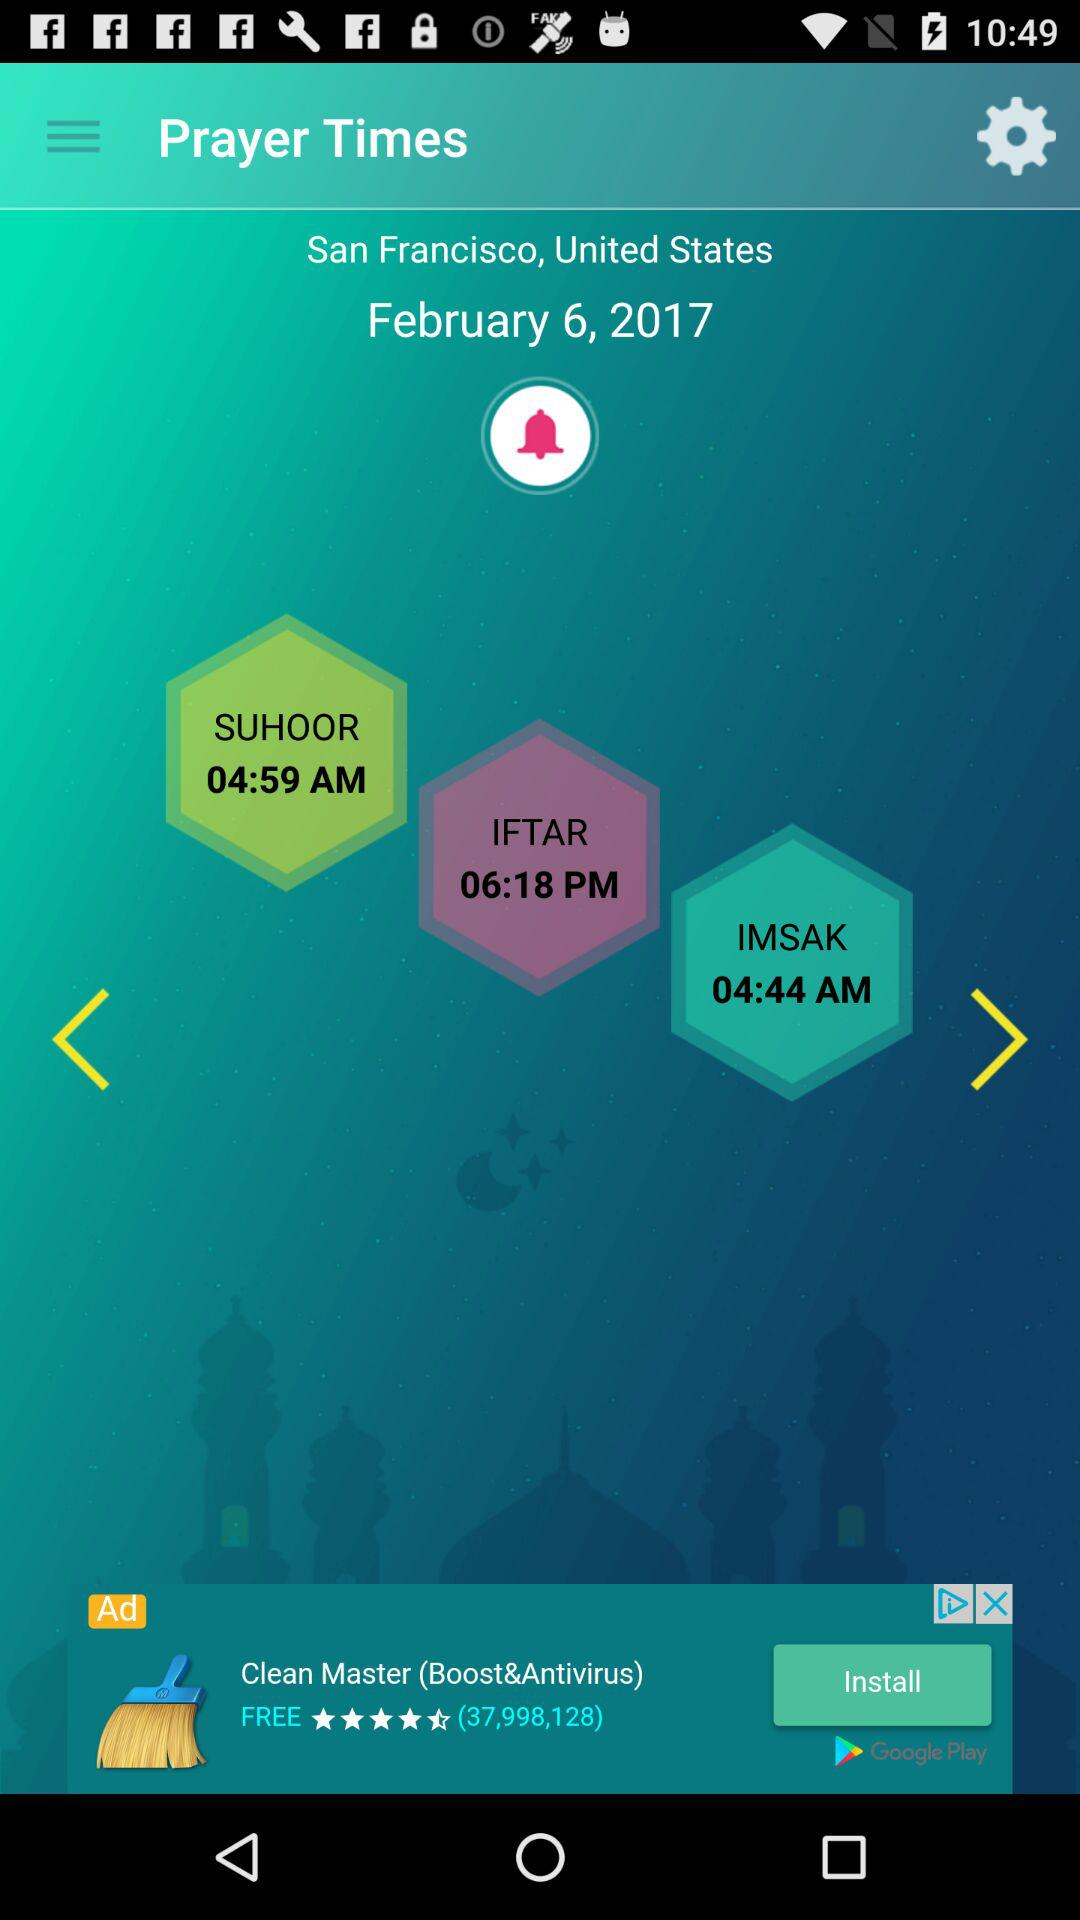What is the location of prayer? The location of prayer is San Francisco, United States. 